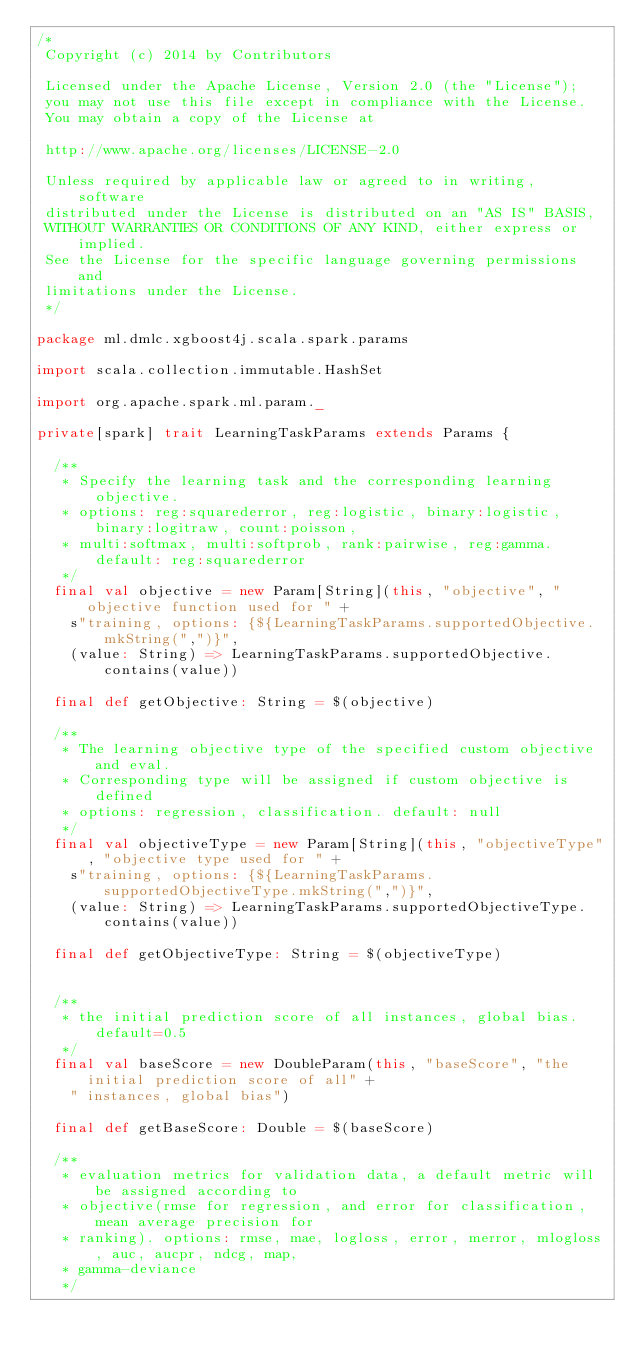Convert code to text. <code><loc_0><loc_0><loc_500><loc_500><_Scala_>/*
 Copyright (c) 2014 by Contributors

 Licensed under the Apache License, Version 2.0 (the "License");
 you may not use this file except in compliance with the License.
 You may obtain a copy of the License at

 http://www.apache.org/licenses/LICENSE-2.0

 Unless required by applicable law or agreed to in writing, software
 distributed under the License is distributed on an "AS IS" BASIS,
 WITHOUT WARRANTIES OR CONDITIONS OF ANY KIND, either express or implied.
 See the License for the specific language governing permissions and
 limitations under the License.
 */

package ml.dmlc.xgboost4j.scala.spark.params

import scala.collection.immutable.HashSet

import org.apache.spark.ml.param._

private[spark] trait LearningTaskParams extends Params {

  /**
   * Specify the learning task and the corresponding learning objective.
   * options: reg:squarederror, reg:logistic, binary:logistic, binary:logitraw, count:poisson,
   * multi:softmax, multi:softprob, rank:pairwise, reg:gamma. default: reg:squarederror
   */
  final val objective = new Param[String](this, "objective", "objective function used for " +
    s"training, options: {${LearningTaskParams.supportedObjective.mkString(",")}",
    (value: String) => LearningTaskParams.supportedObjective.contains(value))

  final def getObjective: String = $(objective)

  /**
   * The learning objective type of the specified custom objective and eval.
   * Corresponding type will be assigned if custom objective is defined
   * options: regression, classification. default: null
   */
  final val objectiveType = new Param[String](this, "objectiveType", "objective type used for " +
    s"training, options: {${LearningTaskParams.supportedObjectiveType.mkString(",")}",
    (value: String) => LearningTaskParams.supportedObjectiveType.contains(value))

  final def getObjectiveType: String = $(objectiveType)


  /**
   * the initial prediction score of all instances, global bias. default=0.5
   */
  final val baseScore = new DoubleParam(this, "baseScore", "the initial prediction score of all" +
    " instances, global bias")

  final def getBaseScore: Double = $(baseScore)

  /**
   * evaluation metrics for validation data, a default metric will be assigned according to
   * objective(rmse for regression, and error for classification, mean average precision for
   * ranking). options: rmse, mae, logloss, error, merror, mlogloss, auc, aucpr, ndcg, map,
   * gamma-deviance
   */</code> 